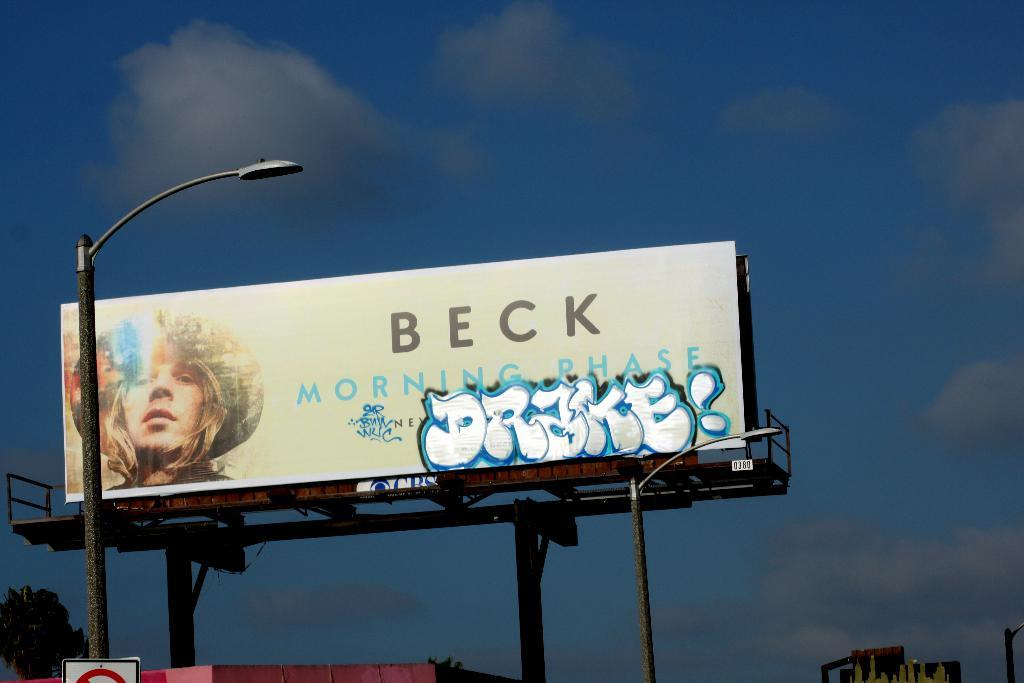<image>
Summarize the visual content of the image. a large billboard with Beck on the top of it 